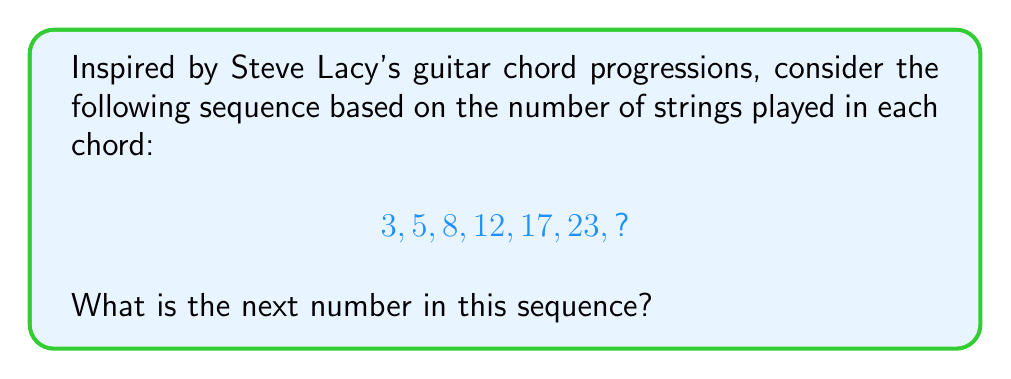Could you help me with this problem? Let's approach this step-by-step:

1) First, let's look at the differences between consecutive terms:
   $5 - 3 = 2$
   $8 - 5 = 3$
   $12 - 8 = 4$
   $17 - 12 = 5$
   $23 - 17 = 6$

2) We can see that the difference is increasing by 1 each time. This suggests an arithmetic sequence of second order.

3) The formula for the nth term of a second-order arithmetic sequence is:

   $$a_n = \frac{n(n-1)}{2} + bn + c$$

   where $b$ and $c$ are constants we need to determine.

4) We can use the first term to find $c$:
   $3 = 0 + b + c$
   $c = 3 - b$

5) Using the second term:
   $5 = 1 + 2b + (3-b)$
   $5 = 1 + b + 3$
   $b = 1$

6) So our sequence formula is:
   $$a_n = \frac{n(n-1)}{2} + n + 2$$

7) To find the next term, we need to calculate $a_7$:
   $$a_7 = \frac{7(7-1)}{2} + 7 + 2$$
   $$a_7 = 21 + 7 + 2 = 30$$

Therefore, the next number in the sequence is 30.
Answer: 30 